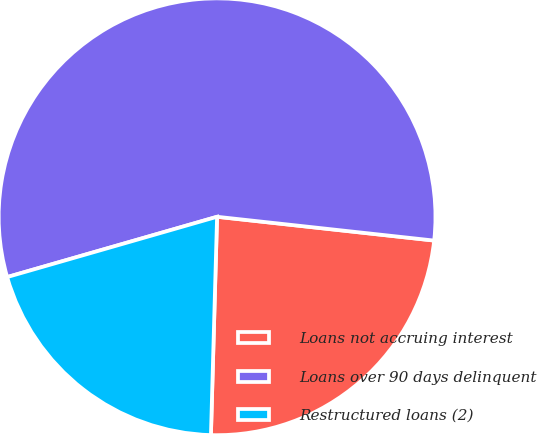Convert chart to OTSL. <chart><loc_0><loc_0><loc_500><loc_500><pie_chart><fcel>Loans not accruing interest<fcel>Loans over 90 days delinquent<fcel>Restructured loans (2)<nl><fcel>23.71%<fcel>56.19%<fcel>20.1%<nl></chart> 